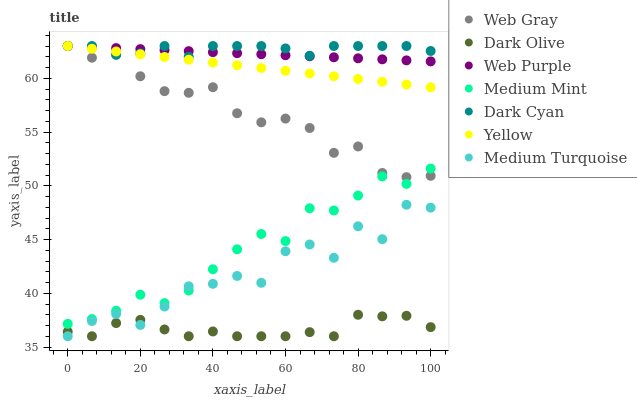Does Dark Olive have the minimum area under the curve?
Answer yes or no. Yes. Does Dark Cyan have the maximum area under the curve?
Answer yes or no. Yes. Does Web Gray have the minimum area under the curve?
Answer yes or no. No. Does Web Gray have the maximum area under the curve?
Answer yes or no. No. Is Yellow the smoothest?
Answer yes or no. Yes. Is Medium Turquoise the roughest?
Answer yes or no. Yes. Is Web Gray the smoothest?
Answer yes or no. No. Is Web Gray the roughest?
Answer yes or no. No. Does Dark Olive have the lowest value?
Answer yes or no. Yes. Does Web Gray have the lowest value?
Answer yes or no. No. Does Dark Cyan have the highest value?
Answer yes or no. Yes. Does Dark Olive have the highest value?
Answer yes or no. No. Is Medium Turquoise less than Web Purple?
Answer yes or no. Yes. Is Web Purple greater than Medium Turquoise?
Answer yes or no. Yes. Does Medium Mint intersect Medium Turquoise?
Answer yes or no. Yes. Is Medium Mint less than Medium Turquoise?
Answer yes or no. No. Is Medium Mint greater than Medium Turquoise?
Answer yes or no. No. Does Medium Turquoise intersect Web Purple?
Answer yes or no. No. 